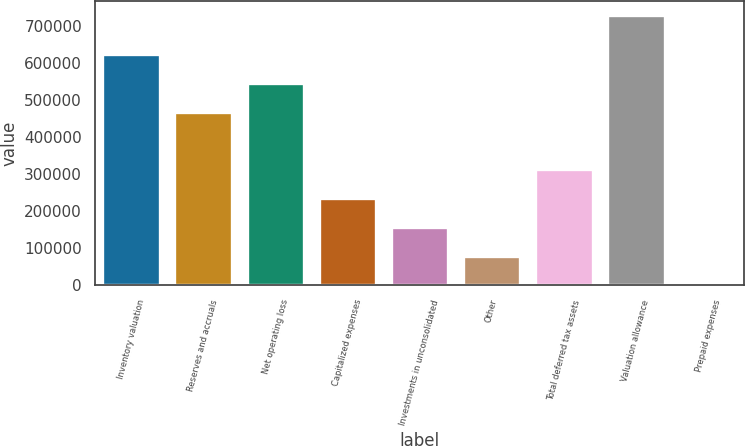<chart> <loc_0><loc_0><loc_500><loc_500><bar_chart><fcel>Inventory valuation<fcel>Reserves and accruals<fcel>Net operating loss<fcel>Capitalized expenses<fcel>Investments in unconsolidated<fcel>Other<fcel>Total deferred tax assets<fcel>Valuation allowance<fcel>Prepaid expenses<nl><fcel>625865<fcel>469504<fcel>547684<fcel>234962<fcel>156781<fcel>78600.6<fcel>313142<fcel>730836<fcel>420<nl></chart> 